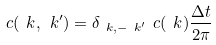Convert formula to latex. <formula><loc_0><loc_0><loc_500><loc_500>c ( \ k , \ k ^ { \prime } ) = \delta _ { \ k , - \ k ^ { \prime } } \ c ( \ k ) \frac { \Delta t } { 2 \pi }</formula> 